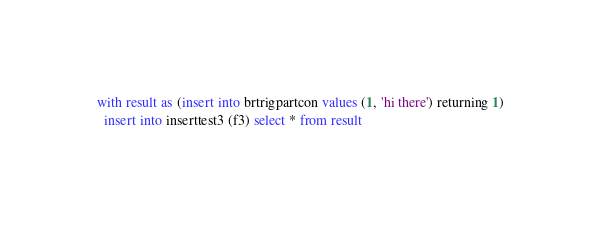Convert code to text. <code><loc_0><loc_0><loc_500><loc_500><_SQL_>with result as (insert into brtrigpartcon values (1, 'hi there') returning 1)
  insert into inserttest3 (f3) select * from result
</code> 